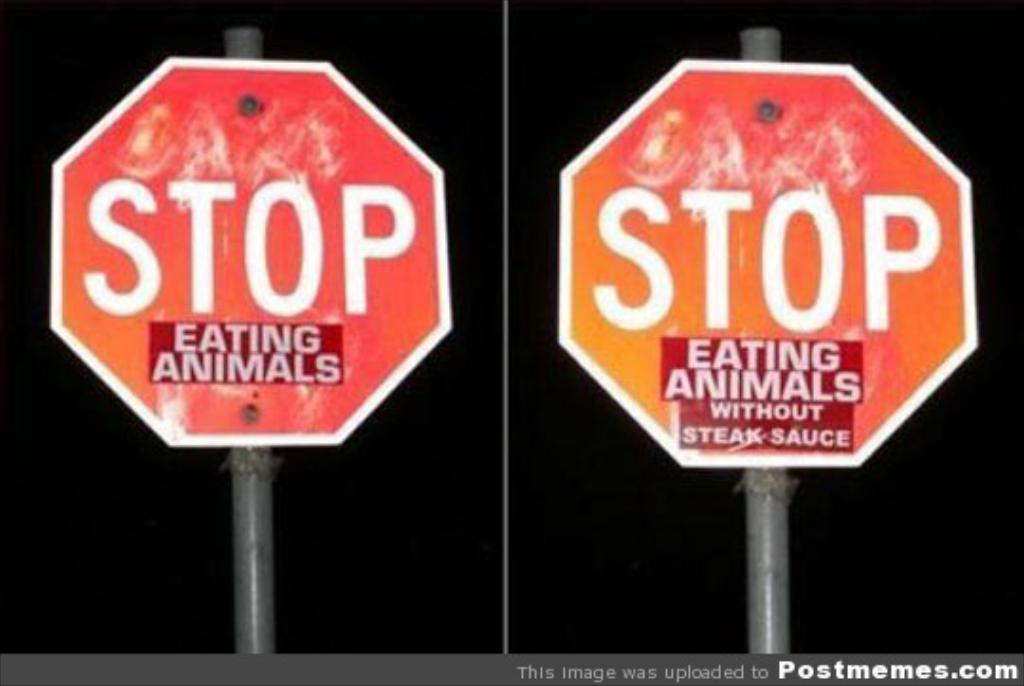The stop sign is referring to what activity?
Your response must be concise. Eating animals. What type of sauce?
Your response must be concise. Steak sauce. 